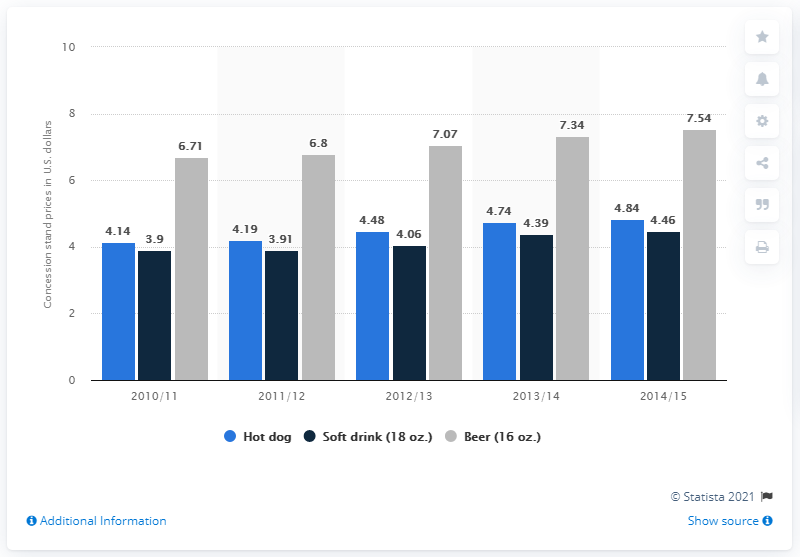Outline some significant characteristics in this image. The average price of a hot dog in 2010/2011 was 4.14 dollars. 